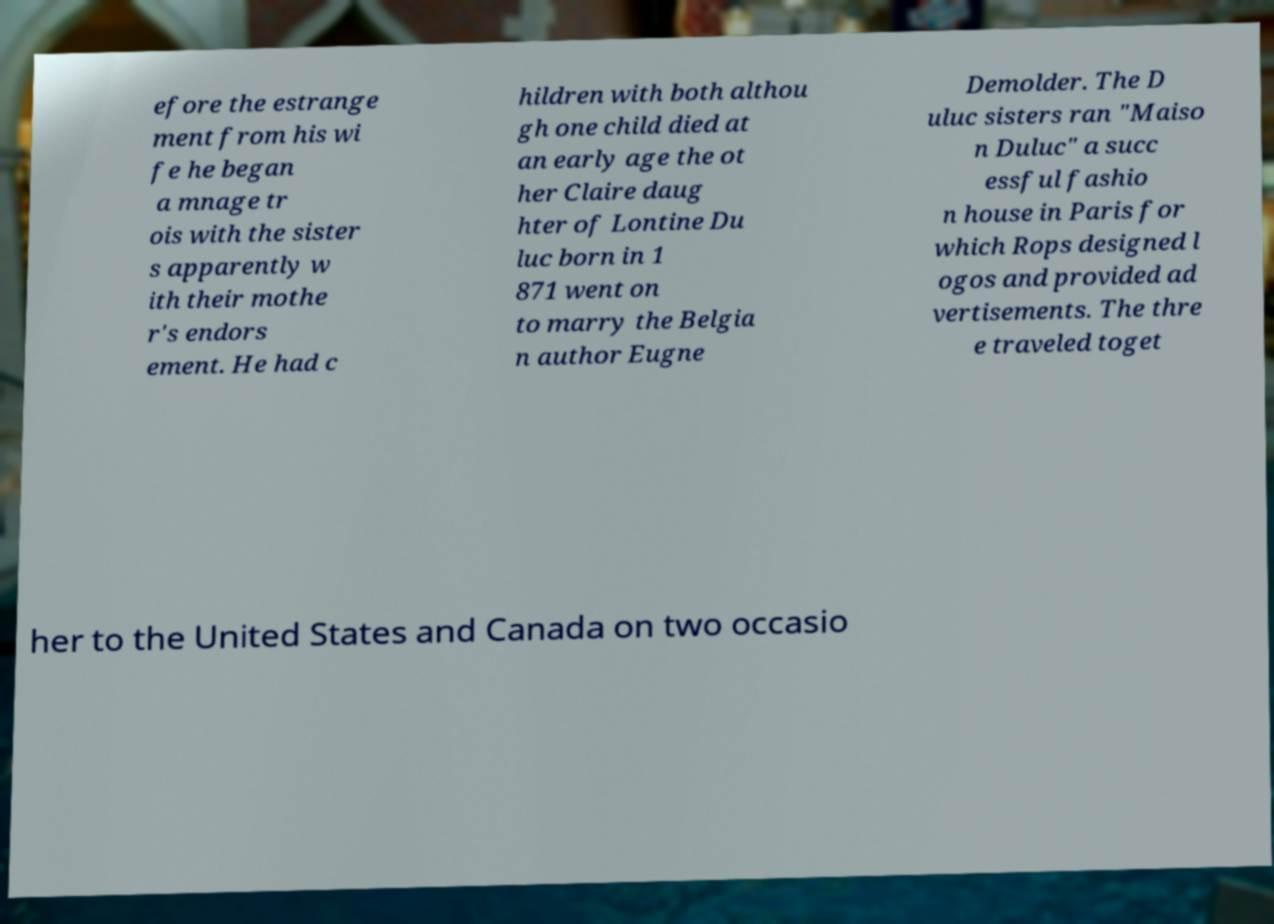Please identify and transcribe the text found in this image. efore the estrange ment from his wi fe he began a mnage tr ois with the sister s apparently w ith their mothe r's endors ement. He had c hildren with both althou gh one child died at an early age the ot her Claire daug hter of Lontine Du luc born in 1 871 went on to marry the Belgia n author Eugne Demolder. The D uluc sisters ran "Maiso n Duluc" a succ essful fashio n house in Paris for which Rops designed l ogos and provided ad vertisements. The thre e traveled toget her to the United States and Canada on two occasio 